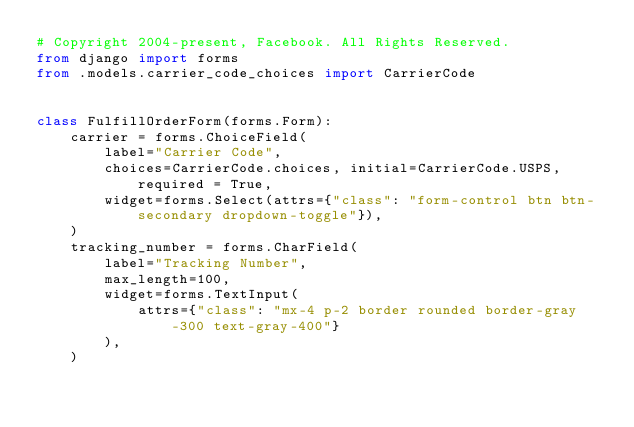Convert code to text. <code><loc_0><loc_0><loc_500><loc_500><_Python_># Copyright 2004-present, Facebook. All Rights Reserved.
from django import forms
from .models.carrier_code_choices import CarrierCode


class FulfillOrderForm(forms.Form):
    carrier = forms.ChoiceField(
        label="Carrier Code",
        choices=CarrierCode.choices, initial=CarrierCode.USPS, required = True,
        widget=forms.Select(attrs={"class": "form-control btn btn-secondary dropdown-toggle"}),
    )
    tracking_number = forms.CharField(
        label="Tracking Number",
        max_length=100,
        widget=forms.TextInput(
            attrs={"class": "mx-4 p-2 border rounded border-gray-300 text-gray-400"}
        ),
    )
</code> 